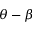Convert formula to latex. <formula><loc_0><loc_0><loc_500><loc_500>\theta - \beta</formula> 